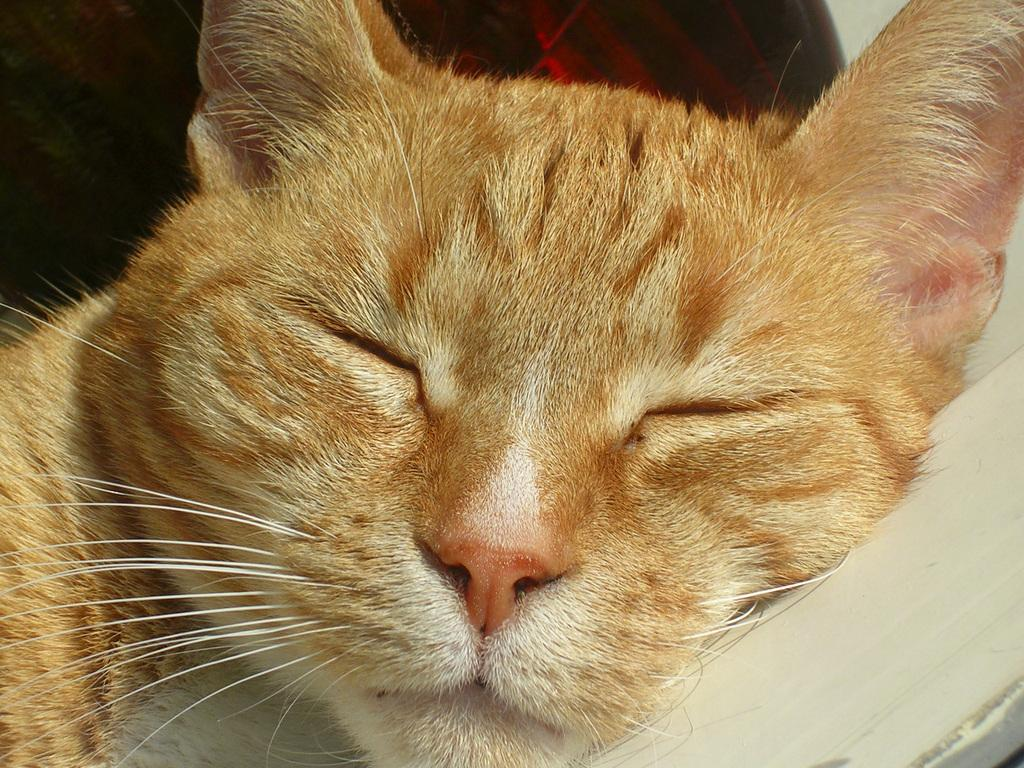What type of animal is in the image? There is a cat in the image. What is the cat doing in the image? The cat is laying on a white object. Where is the crowd gathered in the image? There is no crowd present in the image; it only features a cat laying on a white object. 